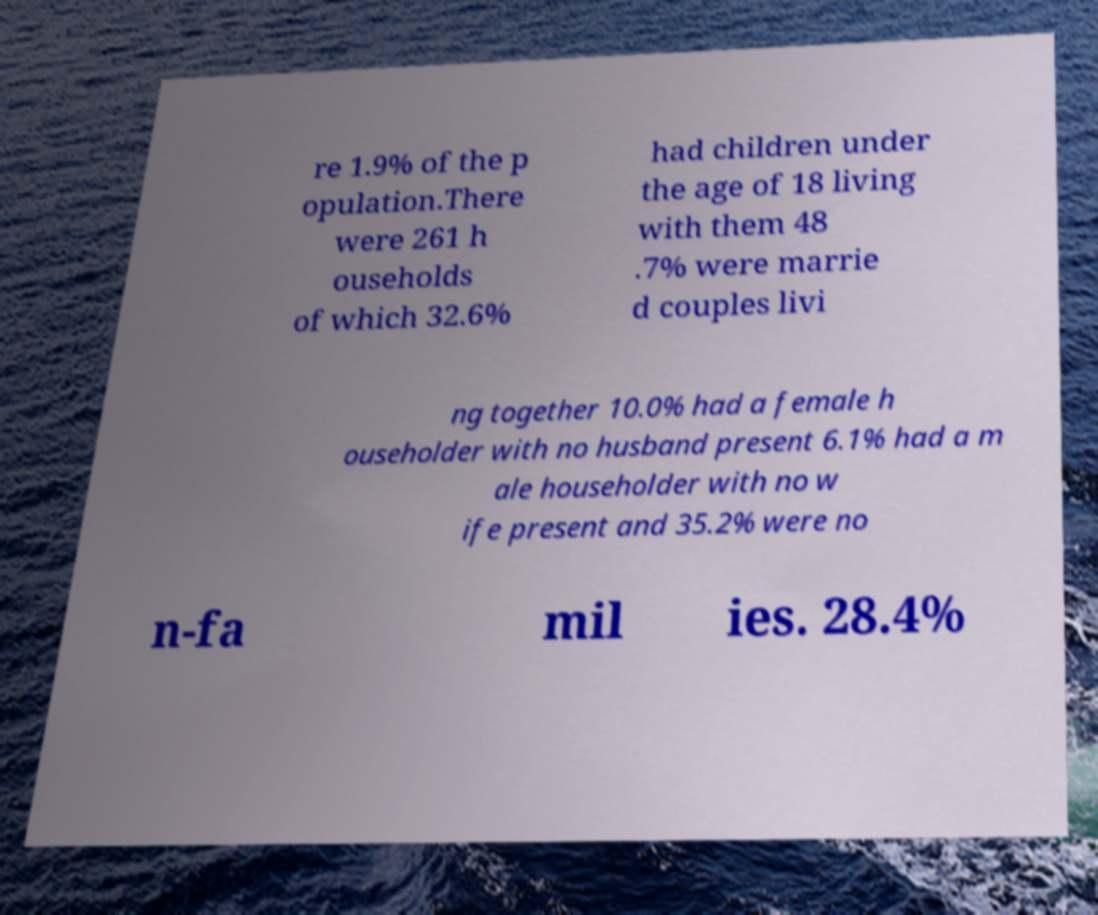I need the written content from this picture converted into text. Can you do that? re 1.9% of the p opulation.There were 261 h ouseholds of which 32.6% had children under the age of 18 living with them 48 .7% were marrie d couples livi ng together 10.0% had a female h ouseholder with no husband present 6.1% had a m ale householder with no w ife present and 35.2% were no n-fa mil ies. 28.4% 